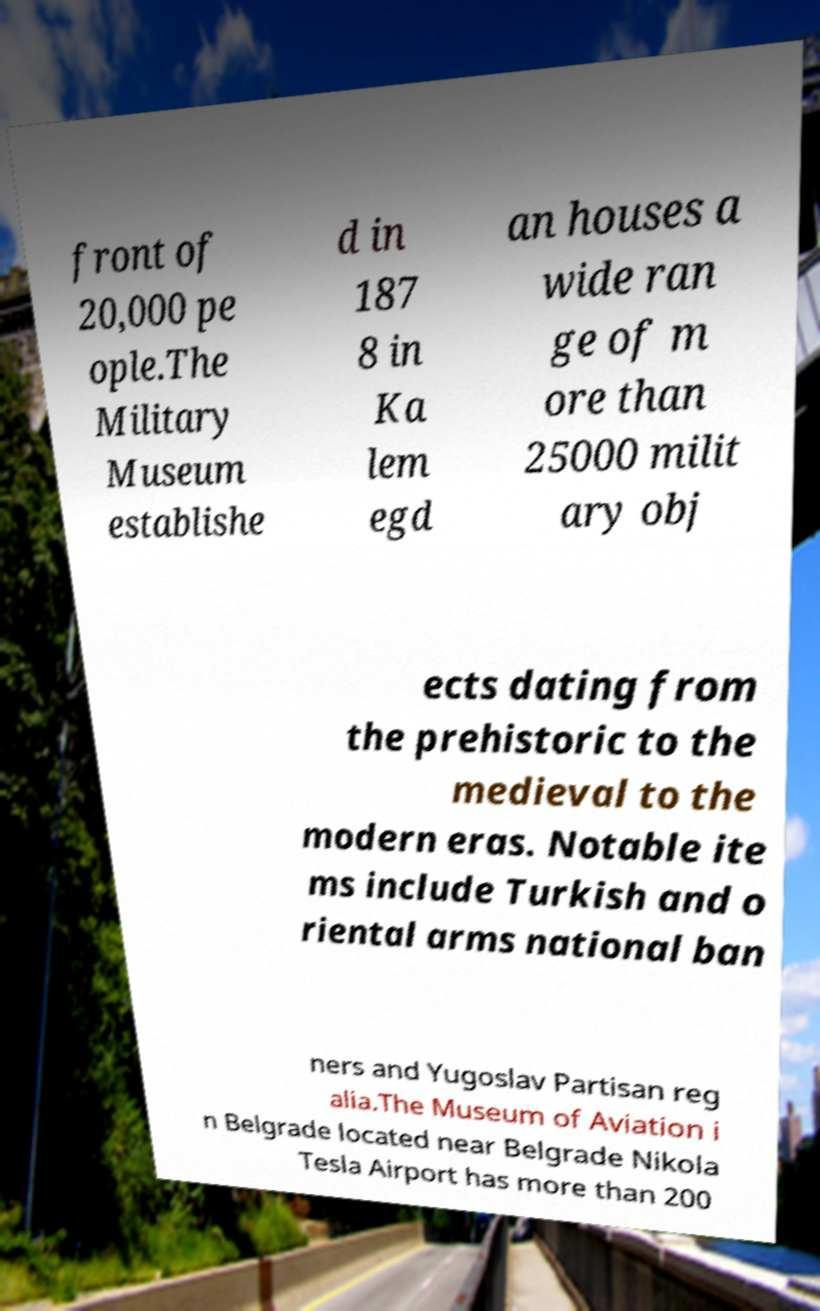I need the written content from this picture converted into text. Can you do that? front of 20,000 pe ople.The Military Museum establishe d in 187 8 in Ka lem egd an houses a wide ran ge of m ore than 25000 milit ary obj ects dating from the prehistoric to the medieval to the modern eras. Notable ite ms include Turkish and o riental arms national ban ners and Yugoslav Partisan reg alia.The Museum of Aviation i n Belgrade located near Belgrade Nikola Tesla Airport has more than 200 